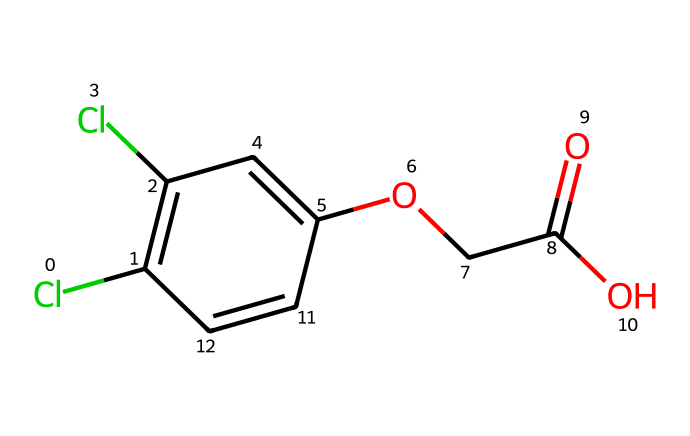What is the primary functional group in 2,4-D? The primary functional group can be identified by looking for characteristic molecular patterns. In 2,4-D, there is a carboxylic acid group (-COOH) indicated by the presence of a carbon atom bonded to a hydroxyl group (-OH) and a carbonyl group (C=O).
Answer: carboxylic acid How many chlorine atoms are present in 2,4-D? The chemical structure depicts two chlorine atoms attached to the phenolic ring of the compound. These can be counted directly from the visual representation of the structure.
Answer: two What is the molecular formula of 2,4-D? By examining the chemical structure, one can account for each type of atom. The count gives us: 8 carbons (C), 6 hydrogens (H), 2 chlorines (Cl), and 4 oxygens (O). Thus, the molecular formula is derived from these counts as C8H6Cl2O4.
Answer: C8H6Cl2O4 What type of pesticide is 2,4-D classified as? The chemical structure and its application suggest that 2,4-D is an herbicide, which is specifically designed to target and eliminate unwanted vegetation, particularly broadleaf weeds.
Answer: herbicide What role does the ether group play in 2,4-D? The ether group in the structure connects the aromatic portion and the carboxylic acid moiety, influencing the solubility and biological activity of the compound. This functionality is crucial for how the herbicide interacts with plant targets.
Answer: connectivity and activity How many rings can be identified in the structure of 2,4-D? The structure contains one aromatic ring which is evident from the alternating double bonds and substituents on the phenyl group. This single ring is key to its classification and function as an herbicide.
Answer: one Which part of the molecule is responsible for the herbicidal activity in 2,4-D? The phenoxy group, which is characterized by the phenol structure and chlorinated functionality, is primarily responsible for the selective herbicidal action of 2,4-D, allowing it to affect target plants effectively.
Answer: phenoxy group 